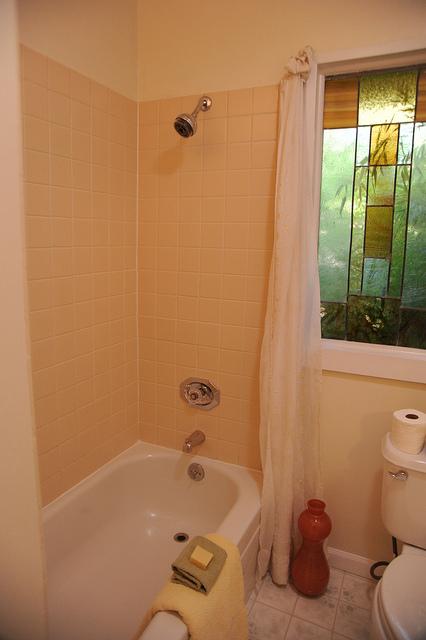Is the window painted?
Answer briefly. Yes. How many bar of soaps are there?
Concise answer only. 1. What color is the wall behind the shower head?
Answer briefly. Peach. 